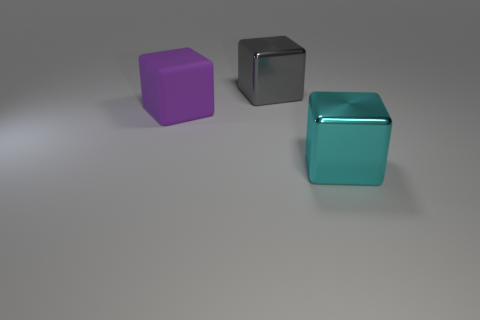Does the rubber cube have the same size as the gray shiny object?
Ensure brevity in your answer.  Yes. What number of things are either cubes that are on the right side of the purple matte cube or large things that are on the left side of the cyan metal object?
Give a very brief answer. 3. There is a metallic thing that is in front of the object that is to the left of the big gray thing; what number of purple rubber things are behind it?
Offer a terse response. 1. What number of other gray cubes are the same size as the gray cube?
Give a very brief answer. 0. There is a cyan metal cube; is its size the same as the metallic object that is left of the cyan metallic thing?
Give a very brief answer. Yes. What number of things are yellow objects or large purple matte objects?
Provide a succinct answer. 1. Is there another gray thing of the same shape as the large matte object?
Provide a short and direct response. Yes. What number of gray things have the same material as the gray block?
Provide a short and direct response. 0. Are the big block right of the big gray cube and the purple thing made of the same material?
Give a very brief answer. No. Are there more large gray metallic things left of the rubber cube than cyan shiny things that are behind the cyan thing?
Give a very brief answer. No. 